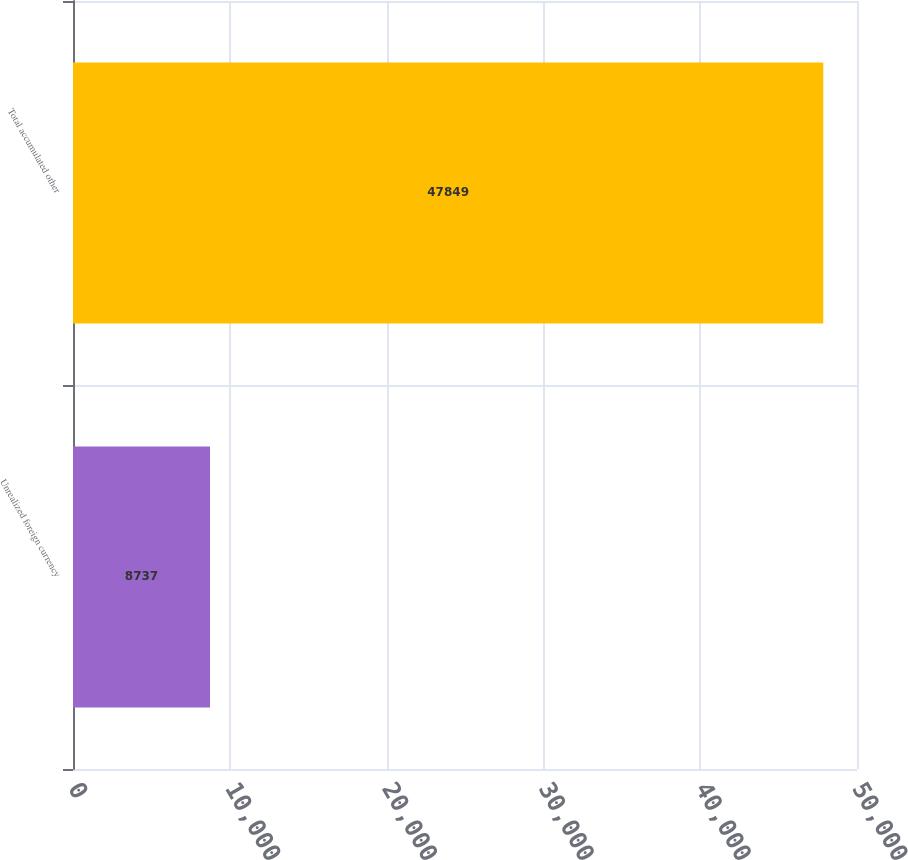<chart> <loc_0><loc_0><loc_500><loc_500><bar_chart><fcel>Unrealized foreign currency<fcel>Total accumulated other<nl><fcel>8737<fcel>47849<nl></chart> 